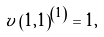Convert formula to latex. <formula><loc_0><loc_0><loc_500><loc_500>v \left ( 1 , 1 \right ) ^ { \left ( 1 \right ) } = 1 ,</formula> 